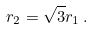<formula> <loc_0><loc_0><loc_500><loc_500>r _ { 2 } = \sqrt { 3 } r _ { 1 } \, .</formula> 